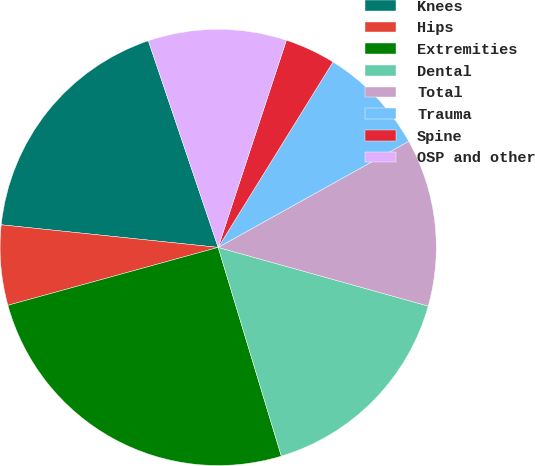Convert chart to OTSL. <chart><loc_0><loc_0><loc_500><loc_500><pie_chart><fcel>Knees<fcel>Hips<fcel>Extremities<fcel>Dental<fcel>Total<fcel>Trauma<fcel>Spine<fcel>OSP and other<nl><fcel>18.16%<fcel>5.93%<fcel>25.4%<fcel>15.99%<fcel>12.42%<fcel>8.09%<fcel>3.76%<fcel>10.25%<nl></chart> 